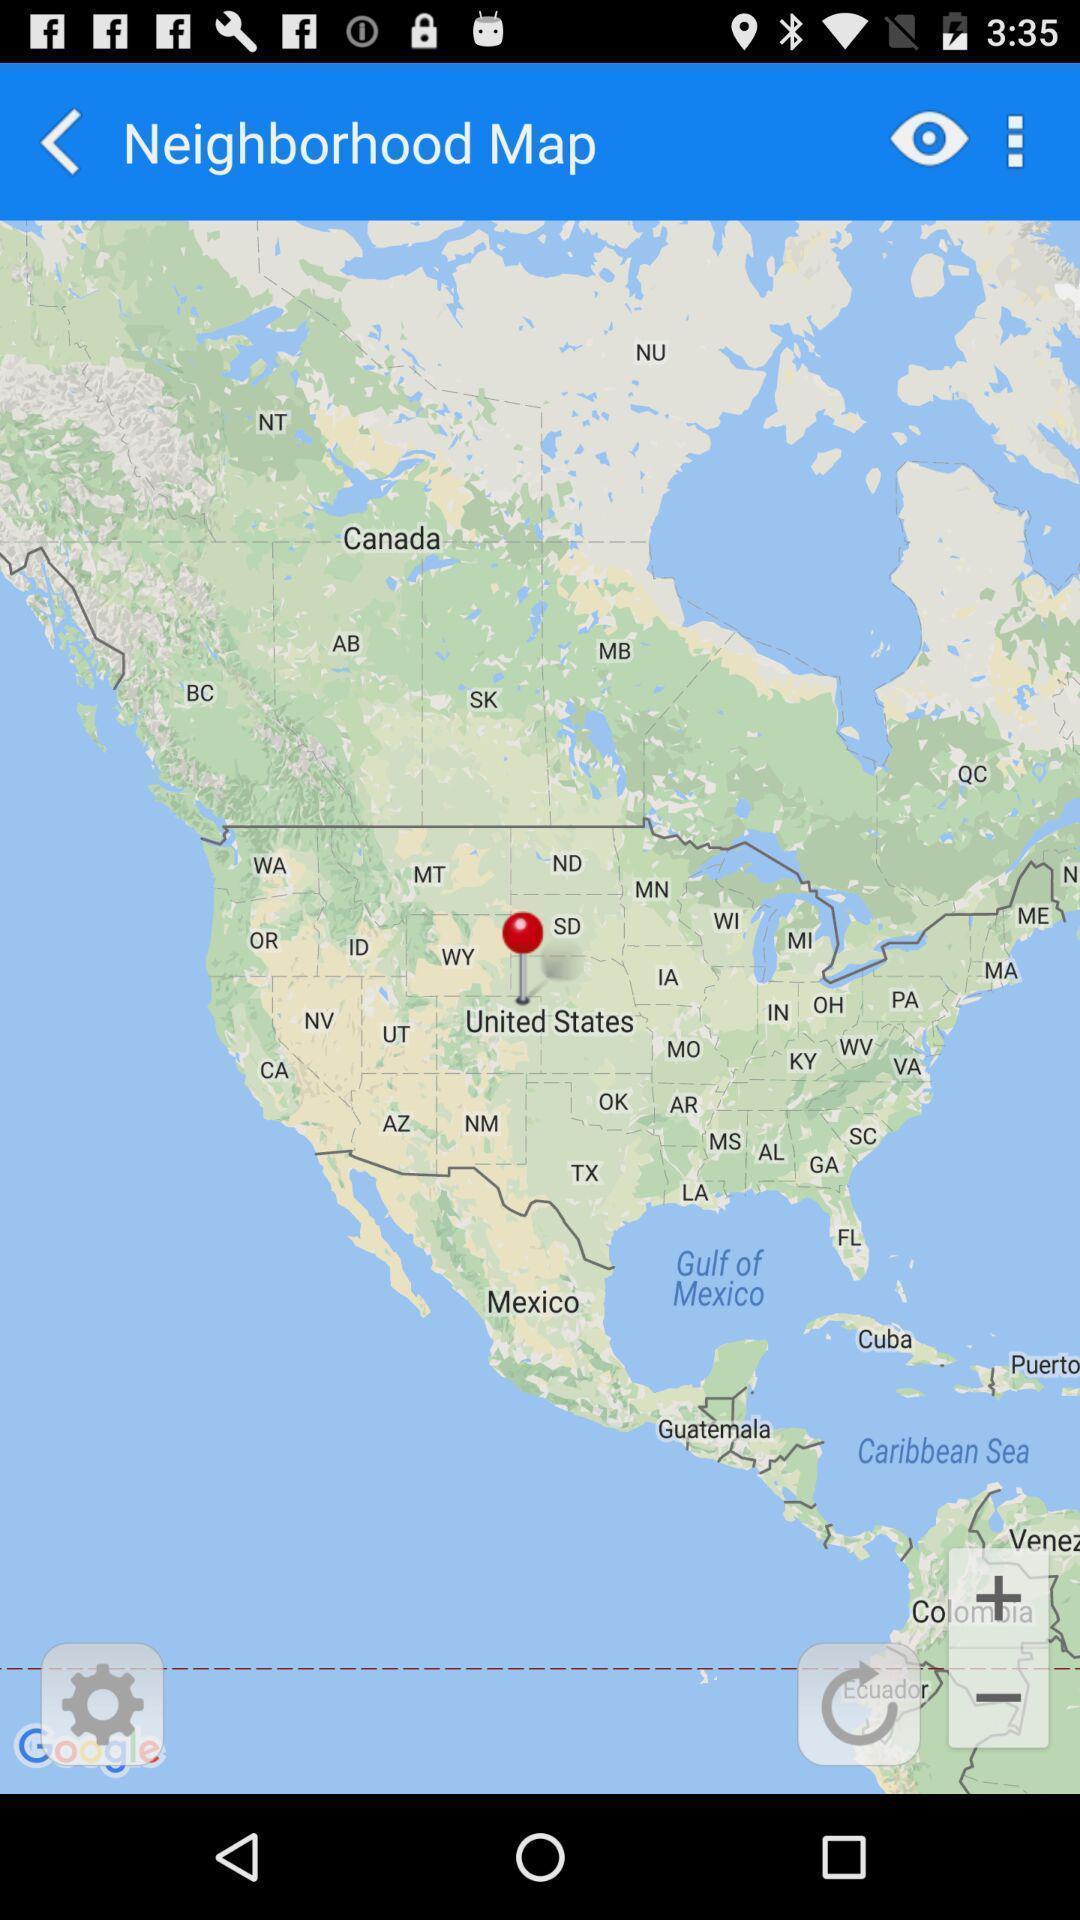Describe the content in this image. Page showing map. 